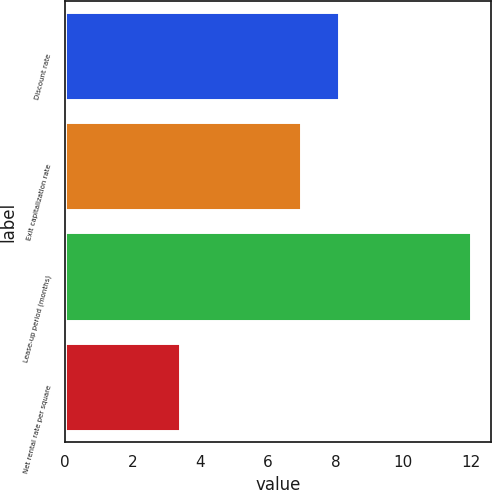Convert chart. <chart><loc_0><loc_0><loc_500><loc_500><bar_chart><fcel>Discount rate<fcel>Exit capitalization rate<fcel>Lease-up period (months)<fcel>Net rental rate per square<nl><fcel>8.1<fcel>6.96<fcel>12<fcel>3.39<nl></chart> 